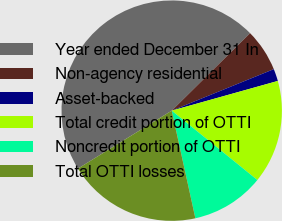<chart> <loc_0><loc_0><loc_500><loc_500><pie_chart><fcel>Year ended December 31 In<fcel>Non-agency residential<fcel>Asset-backed<fcel>Total credit portion of OTTI<fcel>Noncredit portion of OTTI<fcel>Total OTTI losses<nl><fcel>46.4%<fcel>6.26%<fcel>1.8%<fcel>15.18%<fcel>10.72%<fcel>19.64%<nl></chart> 